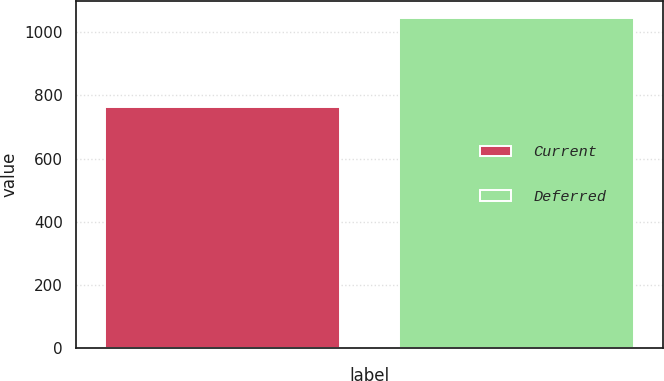<chart> <loc_0><loc_0><loc_500><loc_500><bar_chart><fcel>Current<fcel>Deferred<nl><fcel>763<fcel>1046<nl></chart> 